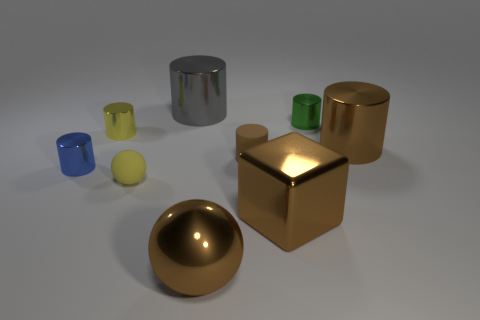What number of other things are there of the same size as the rubber cylinder?
Keep it short and to the point. 4. Does the large metallic cube have the same color as the rubber cylinder?
Your answer should be very brief. Yes. What is the shape of the small metallic object that is behind the small yellow thing behind the brown thing that is on the right side of the green cylinder?
Make the answer very short. Cylinder. What number of objects are either big metal cylinders to the left of the small green metal cylinder or tiny metal objects in front of the small green metal thing?
Your answer should be very brief. 3. There is a metal cylinder that is in front of the brown cylinder in front of the big brown cylinder; what size is it?
Provide a short and direct response. Small. Do the big object right of the tiny green object and the shiny sphere have the same color?
Provide a succinct answer. Yes. Is there a small green object of the same shape as the blue metal thing?
Your response must be concise. Yes. The rubber sphere that is the same size as the yellow cylinder is what color?
Keep it short and to the point. Yellow. What is the size of the ball to the right of the big gray object?
Your answer should be compact. Large. Are there any metallic things that are in front of the tiny matte thing left of the big gray shiny thing?
Provide a succinct answer. Yes. 